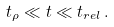Convert formula to latex. <formula><loc_0><loc_0><loc_500><loc_500>t _ { \rho } \ll t \ll t _ { r e l } \, .</formula> 